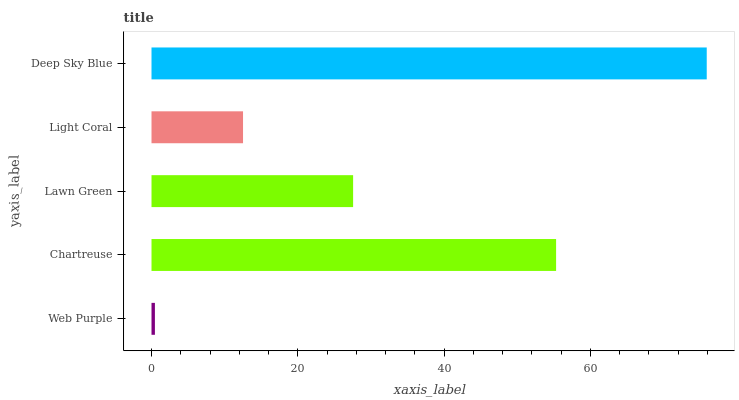Is Web Purple the minimum?
Answer yes or no. Yes. Is Deep Sky Blue the maximum?
Answer yes or no. Yes. Is Chartreuse the minimum?
Answer yes or no. No. Is Chartreuse the maximum?
Answer yes or no. No. Is Chartreuse greater than Web Purple?
Answer yes or no. Yes. Is Web Purple less than Chartreuse?
Answer yes or no. Yes. Is Web Purple greater than Chartreuse?
Answer yes or no. No. Is Chartreuse less than Web Purple?
Answer yes or no. No. Is Lawn Green the high median?
Answer yes or no. Yes. Is Lawn Green the low median?
Answer yes or no. Yes. Is Light Coral the high median?
Answer yes or no. No. Is Light Coral the low median?
Answer yes or no. No. 